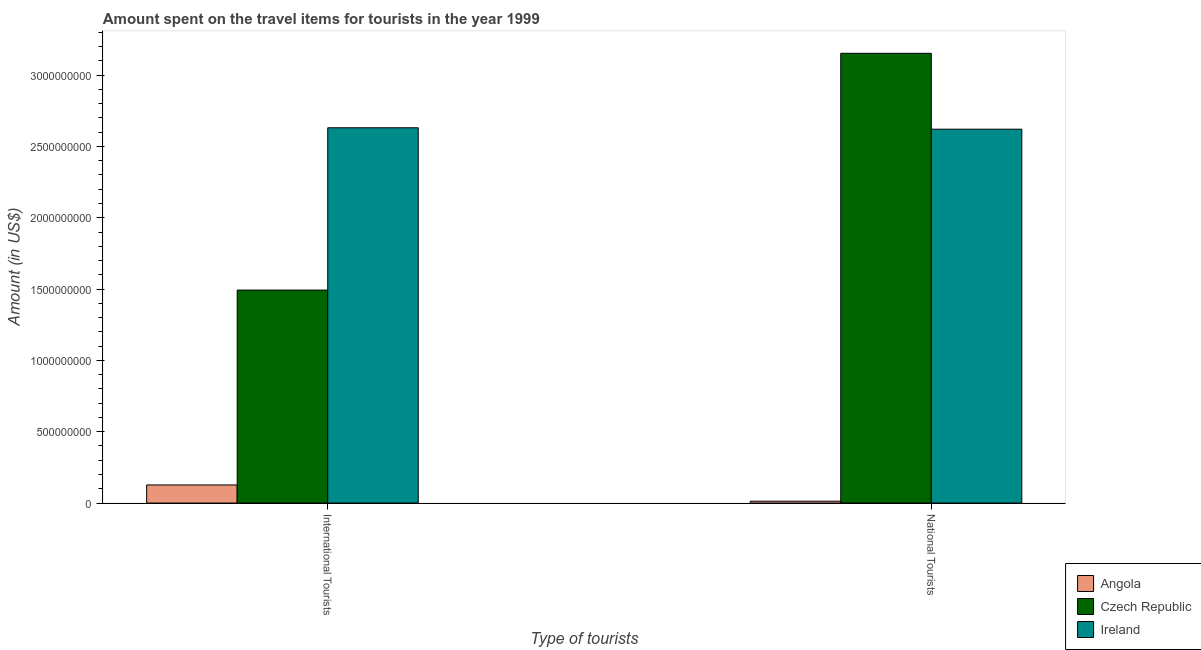What is the label of the 1st group of bars from the left?
Make the answer very short. International Tourists. What is the amount spent on travel items of international tourists in Czech Republic?
Provide a short and direct response. 1.49e+09. Across all countries, what is the maximum amount spent on travel items of international tourists?
Your response must be concise. 2.63e+09. Across all countries, what is the minimum amount spent on travel items of national tourists?
Ensure brevity in your answer.  1.30e+07. In which country was the amount spent on travel items of national tourists maximum?
Keep it short and to the point. Czech Republic. In which country was the amount spent on travel items of national tourists minimum?
Offer a very short reply. Angola. What is the total amount spent on travel items of international tourists in the graph?
Your answer should be very brief. 4.25e+09. What is the difference between the amount spent on travel items of national tourists in Ireland and that in Czech Republic?
Provide a succinct answer. -5.32e+08. What is the difference between the amount spent on travel items of national tourists in Ireland and the amount spent on travel items of international tourists in Czech Republic?
Provide a short and direct response. 1.13e+09. What is the average amount spent on travel items of international tourists per country?
Provide a short and direct response. 1.42e+09. What is the difference between the amount spent on travel items of national tourists and amount spent on travel items of international tourists in Czech Republic?
Your answer should be compact. 1.66e+09. What is the ratio of the amount spent on travel items of international tourists in Czech Republic to that in Ireland?
Give a very brief answer. 0.57. What does the 2nd bar from the left in National Tourists represents?
Your answer should be very brief. Czech Republic. What does the 1st bar from the right in International Tourists represents?
Offer a terse response. Ireland. How many countries are there in the graph?
Ensure brevity in your answer.  3. What is the difference between two consecutive major ticks on the Y-axis?
Your answer should be compact. 5.00e+08. How many legend labels are there?
Your answer should be very brief. 3. How are the legend labels stacked?
Offer a very short reply. Vertical. What is the title of the graph?
Provide a short and direct response. Amount spent on the travel items for tourists in the year 1999. Does "Tanzania" appear as one of the legend labels in the graph?
Provide a succinct answer. No. What is the label or title of the X-axis?
Ensure brevity in your answer.  Type of tourists. What is the Amount (in US$) in Angola in International Tourists?
Your response must be concise. 1.27e+08. What is the Amount (in US$) of Czech Republic in International Tourists?
Ensure brevity in your answer.  1.49e+09. What is the Amount (in US$) in Ireland in International Tourists?
Offer a very short reply. 2.63e+09. What is the Amount (in US$) in Angola in National Tourists?
Make the answer very short. 1.30e+07. What is the Amount (in US$) in Czech Republic in National Tourists?
Your answer should be very brief. 3.15e+09. What is the Amount (in US$) in Ireland in National Tourists?
Make the answer very short. 2.62e+09. Across all Type of tourists, what is the maximum Amount (in US$) of Angola?
Give a very brief answer. 1.27e+08. Across all Type of tourists, what is the maximum Amount (in US$) of Czech Republic?
Your response must be concise. 3.15e+09. Across all Type of tourists, what is the maximum Amount (in US$) of Ireland?
Your answer should be very brief. 2.63e+09. Across all Type of tourists, what is the minimum Amount (in US$) in Angola?
Make the answer very short. 1.30e+07. Across all Type of tourists, what is the minimum Amount (in US$) of Czech Republic?
Provide a succinct answer. 1.49e+09. Across all Type of tourists, what is the minimum Amount (in US$) of Ireland?
Offer a terse response. 2.62e+09. What is the total Amount (in US$) in Angola in the graph?
Ensure brevity in your answer.  1.40e+08. What is the total Amount (in US$) of Czech Republic in the graph?
Provide a short and direct response. 4.65e+09. What is the total Amount (in US$) in Ireland in the graph?
Keep it short and to the point. 5.25e+09. What is the difference between the Amount (in US$) in Angola in International Tourists and that in National Tourists?
Provide a short and direct response. 1.14e+08. What is the difference between the Amount (in US$) in Czech Republic in International Tourists and that in National Tourists?
Your answer should be very brief. -1.66e+09. What is the difference between the Amount (in US$) of Angola in International Tourists and the Amount (in US$) of Czech Republic in National Tourists?
Offer a very short reply. -3.03e+09. What is the difference between the Amount (in US$) in Angola in International Tourists and the Amount (in US$) in Ireland in National Tourists?
Give a very brief answer. -2.49e+09. What is the difference between the Amount (in US$) of Czech Republic in International Tourists and the Amount (in US$) of Ireland in National Tourists?
Offer a terse response. -1.13e+09. What is the average Amount (in US$) of Angola per Type of tourists?
Provide a short and direct response. 7.00e+07. What is the average Amount (in US$) in Czech Republic per Type of tourists?
Ensure brevity in your answer.  2.32e+09. What is the average Amount (in US$) of Ireland per Type of tourists?
Your answer should be very brief. 2.63e+09. What is the difference between the Amount (in US$) in Angola and Amount (in US$) in Czech Republic in International Tourists?
Offer a very short reply. -1.37e+09. What is the difference between the Amount (in US$) in Angola and Amount (in US$) in Ireland in International Tourists?
Ensure brevity in your answer.  -2.50e+09. What is the difference between the Amount (in US$) in Czech Republic and Amount (in US$) in Ireland in International Tourists?
Your response must be concise. -1.14e+09. What is the difference between the Amount (in US$) in Angola and Amount (in US$) in Czech Republic in National Tourists?
Ensure brevity in your answer.  -3.14e+09. What is the difference between the Amount (in US$) of Angola and Amount (in US$) of Ireland in National Tourists?
Ensure brevity in your answer.  -2.61e+09. What is the difference between the Amount (in US$) of Czech Republic and Amount (in US$) of Ireland in National Tourists?
Offer a terse response. 5.32e+08. What is the ratio of the Amount (in US$) of Angola in International Tourists to that in National Tourists?
Provide a short and direct response. 9.77. What is the ratio of the Amount (in US$) in Czech Republic in International Tourists to that in National Tourists?
Give a very brief answer. 0.47. What is the ratio of the Amount (in US$) in Ireland in International Tourists to that in National Tourists?
Your answer should be very brief. 1. What is the difference between the highest and the second highest Amount (in US$) in Angola?
Provide a short and direct response. 1.14e+08. What is the difference between the highest and the second highest Amount (in US$) of Czech Republic?
Offer a very short reply. 1.66e+09. What is the difference between the highest and the second highest Amount (in US$) in Ireland?
Your answer should be compact. 1.00e+07. What is the difference between the highest and the lowest Amount (in US$) in Angola?
Provide a succinct answer. 1.14e+08. What is the difference between the highest and the lowest Amount (in US$) in Czech Republic?
Offer a very short reply. 1.66e+09. What is the difference between the highest and the lowest Amount (in US$) in Ireland?
Provide a short and direct response. 1.00e+07. 